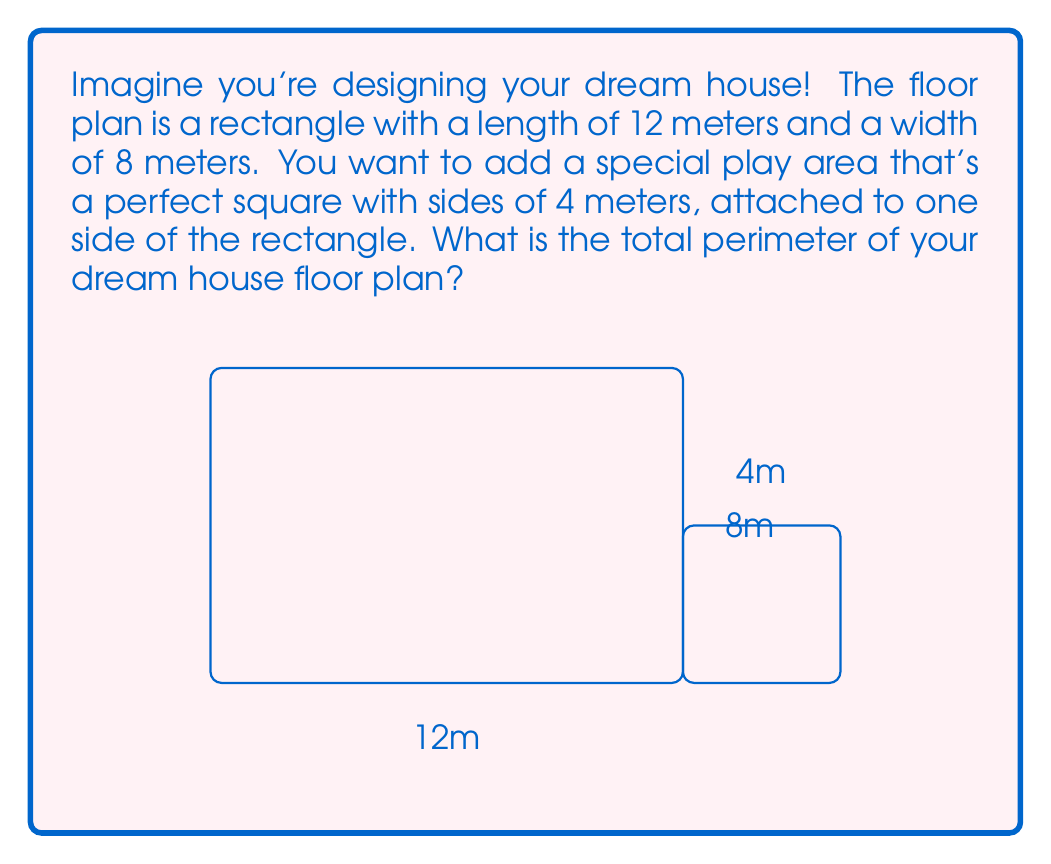What is the answer to this math problem? Let's solve this step-by-step:

1. First, we need to find the perimeter of the main rectangular part:
   - Length of rectangle = 12 meters
   - Width of rectangle = 8 meters
   - Perimeter of rectangle = $2 \times (length + width)$
   - $P_{rectangle} = 2 \times (12 + 8) = 2 \times 20 = 40$ meters

2. Now, let's look at the square play area:
   - Side of square = 4 meters
   - The square is attached to one side of the rectangle

3. When we add the square, we need to:
   - Add three sides of the square (4 + 4 + 4 = 12 meters)
   - Subtract the side of the rectangle where the square is attached (8 meters)

4. So, the final calculation is:
   $P_{total} = P_{rectangle} + 3 \times side_{square} - width_{rectangle}$
   $P_{total} = 40 + (3 \times 4) - 8$
   $P_{total} = 40 + 12 - 8 = 44$ meters

Therefore, the total perimeter of your dream house floor plan is 44 meters.
Answer: 44 meters 